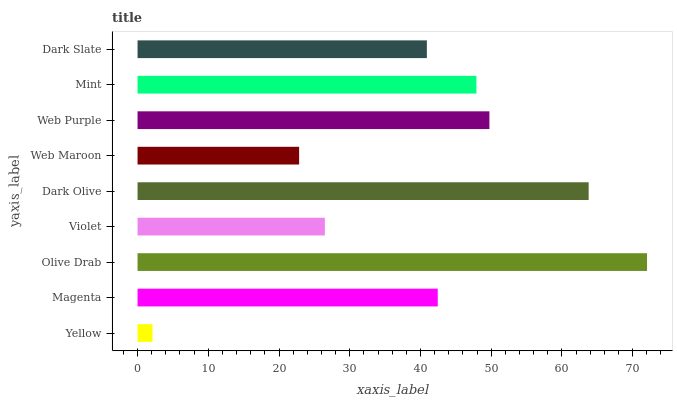Is Yellow the minimum?
Answer yes or no. Yes. Is Olive Drab the maximum?
Answer yes or no. Yes. Is Magenta the minimum?
Answer yes or no. No. Is Magenta the maximum?
Answer yes or no. No. Is Magenta greater than Yellow?
Answer yes or no. Yes. Is Yellow less than Magenta?
Answer yes or no. Yes. Is Yellow greater than Magenta?
Answer yes or no. No. Is Magenta less than Yellow?
Answer yes or no. No. Is Magenta the high median?
Answer yes or no. Yes. Is Magenta the low median?
Answer yes or no. Yes. Is Web Maroon the high median?
Answer yes or no. No. Is Violet the low median?
Answer yes or no. No. 